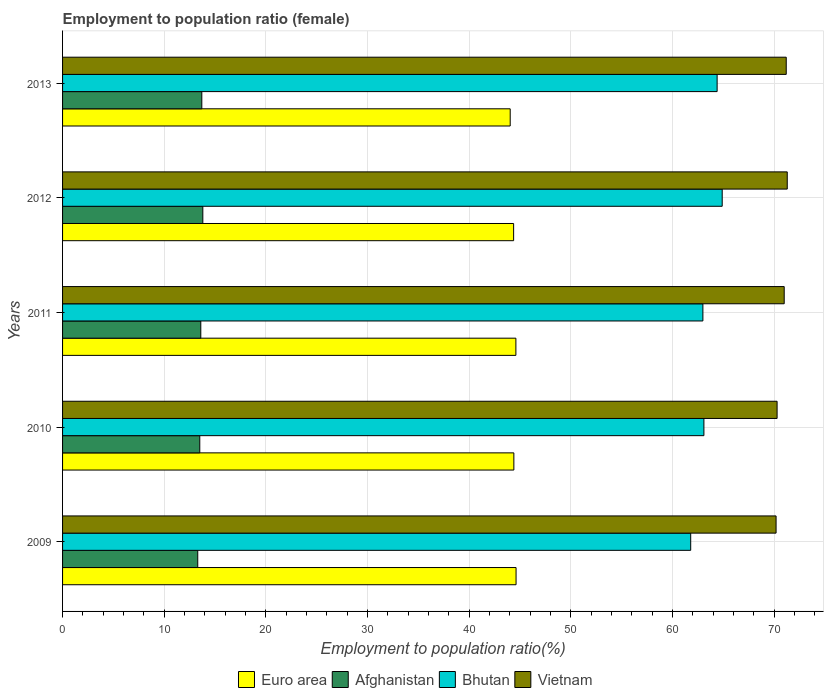How many different coloured bars are there?
Give a very brief answer. 4. How many groups of bars are there?
Offer a terse response. 5. Are the number of bars per tick equal to the number of legend labels?
Provide a succinct answer. Yes. Are the number of bars on each tick of the Y-axis equal?
Offer a terse response. Yes. How many bars are there on the 2nd tick from the top?
Keep it short and to the point. 4. How many bars are there on the 2nd tick from the bottom?
Your answer should be very brief. 4. What is the employment to population ratio in Afghanistan in 2011?
Offer a terse response. 13.6. Across all years, what is the maximum employment to population ratio in Afghanistan?
Offer a terse response. 13.8. Across all years, what is the minimum employment to population ratio in Afghanistan?
Ensure brevity in your answer.  13.3. What is the total employment to population ratio in Vietnam in the graph?
Offer a very short reply. 354. What is the difference between the employment to population ratio in Vietnam in 2009 and that in 2011?
Make the answer very short. -0.8. What is the difference between the employment to population ratio in Bhutan in 2013 and the employment to population ratio in Euro area in 2012?
Your answer should be very brief. 20.02. What is the average employment to population ratio in Bhutan per year?
Your answer should be compact. 63.44. In the year 2012, what is the difference between the employment to population ratio in Bhutan and employment to population ratio in Euro area?
Offer a very short reply. 20.52. What is the ratio of the employment to population ratio in Euro area in 2010 to that in 2011?
Give a very brief answer. 1. What is the difference between the highest and the second highest employment to population ratio in Euro area?
Your answer should be very brief. 0.02. What is the difference between the highest and the lowest employment to population ratio in Vietnam?
Keep it short and to the point. 1.1. In how many years, is the employment to population ratio in Bhutan greater than the average employment to population ratio in Bhutan taken over all years?
Your response must be concise. 2. Is the sum of the employment to population ratio in Bhutan in 2010 and 2012 greater than the maximum employment to population ratio in Afghanistan across all years?
Offer a very short reply. Yes. What does the 4th bar from the top in 2011 represents?
Give a very brief answer. Euro area. What does the 4th bar from the bottom in 2011 represents?
Your answer should be compact. Vietnam. Is it the case that in every year, the sum of the employment to population ratio in Vietnam and employment to population ratio in Bhutan is greater than the employment to population ratio in Afghanistan?
Give a very brief answer. Yes. How many years are there in the graph?
Provide a short and direct response. 5. Are the values on the major ticks of X-axis written in scientific E-notation?
Ensure brevity in your answer.  No. Does the graph contain any zero values?
Ensure brevity in your answer.  No. Where does the legend appear in the graph?
Offer a terse response. Bottom center. How are the legend labels stacked?
Your response must be concise. Horizontal. What is the title of the graph?
Keep it short and to the point. Employment to population ratio (female). What is the Employment to population ratio(%) of Euro area in 2009?
Provide a short and direct response. 44.62. What is the Employment to population ratio(%) in Afghanistan in 2009?
Make the answer very short. 13.3. What is the Employment to population ratio(%) of Bhutan in 2009?
Give a very brief answer. 61.8. What is the Employment to population ratio(%) of Vietnam in 2009?
Make the answer very short. 70.2. What is the Employment to population ratio(%) of Euro area in 2010?
Your answer should be very brief. 44.4. What is the Employment to population ratio(%) of Afghanistan in 2010?
Provide a succinct answer. 13.5. What is the Employment to population ratio(%) in Bhutan in 2010?
Make the answer very short. 63.1. What is the Employment to population ratio(%) in Vietnam in 2010?
Keep it short and to the point. 70.3. What is the Employment to population ratio(%) in Euro area in 2011?
Provide a short and direct response. 44.6. What is the Employment to population ratio(%) of Afghanistan in 2011?
Your answer should be compact. 13.6. What is the Employment to population ratio(%) in Bhutan in 2011?
Offer a terse response. 63. What is the Employment to population ratio(%) in Vietnam in 2011?
Offer a very short reply. 71. What is the Employment to population ratio(%) of Euro area in 2012?
Give a very brief answer. 44.38. What is the Employment to population ratio(%) of Afghanistan in 2012?
Give a very brief answer. 13.8. What is the Employment to population ratio(%) of Bhutan in 2012?
Provide a succinct answer. 64.9. What is the Employment to population ratio(%) of Vietnam in 2012?
Provide a succinct answer. 71.3. What is the Employment to population ratio(%) of Euro area in 2013?
Provide a succinct answer. 44.04. What is the Employment to population ratio(%) in Afghanistan in 2013?
Offer a very short reply. 13.7. What is the Employment to population ratio(%) in Bhutan in 2013?
Provide a short and direct response. 64.4. What is the Employment to population ratio(%) of Vietnam in 2013?
Your response must be concise. 71.2. Across all years, what is the maximum Employment to population ratio(%) in Euro area?
Make the answer very short. 44.62. Across all years, what is the maximum Employment to population ratio(%) in Afghanistan?
Make the answer very short. 13.8. Across all years, what is the maximum Employment to population ratio(%) in Bhutan?
Ensure brevity in your answer.  64.9. Across all years, what is the maximum Employment to population ratio(%) of Vietnam?
Make the answer very short. 71.3. Across all years, what is the minimum Employment to population ratio(%) in Euro area?
Ensure brevity in your answer.  44.04. Across all years, what is the minimum Employment to population ratio(%) of Afghanistan?
Give a very brief answer. 13.3. Across all years, what is the minimum Employment to population ratio(%) of Bhutan?
Your answer should be very brief. 61.8. Across all years, what is the minimum Employment to population ratio(%) in Vietnam?
Offer a terse response. 70.2. What is the total Employment to population ratio(%) in Euro area in the graph?
Your answer should be very brief. 222.04. What is the total Employment to population ratio(%) in Afghanistan in the graph?
Provide a succinct answer. 67.9. What is the total Employment to population ratio(%) of Bhutan in the graph?
Your response must be concise. 317.2. What is the total Employment to population ratio(%) in Vietnam in the graph?
Offer a very short reply. 354. What is the difference between the Employment to population ratio(%) of Euro area in 2009 and that in 2010?
Provide a short and direct response. 0.22. What is the difference between the Employment to population ratio(%) of Afghanistan in 2009 and that in 2010?
Provide a succinct answer. -0.2. What is the difference between the Employment to population ratio(%) in Bhutan in 2009 and that in 2010?
Provide a short and direct response. -1.3. What is the difference between the Employment to population ratio(%) in Vietnam in 2009 and that in 2010?
Provide a succinct answer. -0.1. What is the difference between the Employment to population ratio(%) in Euro area in 2009 and that in 2011?
Give a very brief answer. 0.02. What is the difference between the Employment to population ratio(%) of Afghanistan in 2009 and that in 2011?
Offer a terse response. -0.3. What is the difference between the Employment to population ratio(%) in Bhutan in 2009 and that in 2011?
Your response must be concise. -1.2. What is the difference between the Employment to population ratio(%) in Euro area in 2009 and that in 2012?
Ensure brevity in your answer.  0.24. What is the difference between the Employment to population ratio(%) in Bhutan in 2009 and that in 2012?
Your answer should be very brief. -3.1. What is the difference between the Employment to population ratio(%) in Vietnam in 2009 and that in 2012?
Offer a very short reply. -1.1. What is the difference between the Employment to population ratio(%) of Euro area in 2009 and that in 2013?
Keep it short and to the point. 0.58. What is the difference between the Employment to population ratio(%) of Vietnam in 2009 and that in 2013?
Offer a terse response. -1. What is the difference between the Employment to population ratio(%) of Euro area in 2010 and that in 2011?
Make the answer very short. -0.2. What is the difference between the Employment to population ratio(%) in Afghanistan in 2010 and that in 2011?
Your answer should be compact. -0.1. What is the difference between the Employment to population ratio(%) of Bhutan in 2010 and that in 2011?
Keep it short and to the point. 0.1. What is the difference between the Employment to population ratio(%) in Euro area in 2010 and that in 2012?
Your response must be concise. 0.02. What is the difference between the Employment to population ratio(%) in Afghanistan in 2010 and that in 2012?
Your response must be concise. -0.3. What is the difference between the Employment to population ratio(%) of Euro area in 2010 and that in 2013?
Give a very brief answer. 0.36. What is the difference between the Employment to population ratio(%) of Euro area in 2011 and that in 2012?
Your answer should be compact. 0.22. What is the difference between the Employment to population ratio(%) in Vietnam in 2011 and that in 2012?
Give a very brief answer. -0.3. What is the difference between the Employment to population ratio(%) of Euro area in 2011 and that in 2013?
Your answer should be compact. 0.56. What is the difference between the Employment to population ratio(%) in Afghanistan in 2011 and that in 2013?
Give a very brief answer. -0.1. What is the difference between the Employment to population ratio(%) in Bhutan in 2011 and that in 2013?
Keep it short and to the point. -1.4. What is the difference between the Employment to population ratio(%) in Euro area in 2012 and that in 2013?
Give a very brief answer. 0.34. What is the difference between the Employment to population ratio(%) of Afghanistan in 2012 and that in 2013?
Ensure brevity in your answer.  0.1. What is the difference between the Employment to population ratio(%) of Bhutan in 2012 and that in 2013?
Offer a terse response. 0.5. What is the difference between the Employment to population ratio(%) in Euro area in 2009 and the Employment to population ratio(%) in Afghanistan in 2010?
Provide a short and direct response. 31.12. What is the difference between the Employment to population ratio(%) of Euro area in 2009 and the Employment to population ratio(%) of Bhutan in 2010?
Ensure brevity in your answer.  -18.48. What is the difference between the Employment to population ratio(%) of Euro area in 2009 and the Employment to population ratio(%) of Vietnam in 2010?
Your answer should be compact. -25.68. What is the difference between the Employment to population ratio(%) in Afghanistan in 2009 and the Employment to population ratio(%) in Bhutan in 2010?
Provide a short and direct response. -49.8. What is the difference between the Employment to population ratio(%) in Afghanistan in 2009 and the Employment to population ratio(%) in Vietnam in 2010?
Your response must be concise. -57. What is the difference between the Employment to population ratio(%) of Bhutan in 2009 and the Employment to population ratio(%) of Vietnam in 2010?
Your answer should be compact. -8.5. What is the difference between the Employment to population ratio(%) in Euro area in 2009 and the Employment to population ratio(%) in Afghanistan in 2011?
Your answer should be compact. 31.02. What is the difference between the Employment to population ratio(%) of Euro area in 2009 and the Employment to population ratio(%) of Bhutan in 2011?
Provide a short and direct response. -18.38. What is the difference between the Employment to population ratio(%) of Euro area in 2009 and the Employment to population ratio(%) of Vietnam in 2011?
Ensure brevity in your answer.  -26.38. What is the difference between the Employment to population ratio(%) of Afghanistan in 2009 and the Employment to population ratio(%) of Bhutan in 2011?
Keep it short and to the point. -49.7. What is the difference between the Employment to population ratio(%) in Afghanistan in 2009 and the Employment to population ratio(%) in Vietnam in 2011?
Make the answer very short. -57.7. What is the difference between the Employment to population ratio(%) of Bhutan in 2009 and the Employment to population ratio(%) of Vietnam in 2011?
Provide a succinct answer. -9.2. What is the difference between the Employment to population ratio(%) of Euro area in 2009 and the Employment to population ratio(%) of Afghanistan in 2012?
Your answer should be very brief. 30.82. What is the difference between the Employment to population ratio(%) of Euro area in 2009 and the Employment to population ratio(%) of Bhutan in 2012?
Ensure brevity in your answer.  -20.28. What is the difference between the Employment to population ratio(%) of Euro area in 2009 and the Employment to population ratio(%) of Vietnam in 2012?
Provide a short and direct response. -26.68. What is the difference between the Employment to population ratio(%) in Afghanistan in 2009 and the Employment to population ratio(%) in Bhutan in 2012?
Ensure brevity in your answer.  -51.6. What is the difference between the Employment to population ratio(%) in Afghanistan in 2009 and the Employment to population ratio(%) in Vietnam in 2012?
Your response must be concise. -58. What is the difference between the Employment to population ratio(%) in Euro area in 2009 and the Employment to population ratio(%) in Afghanistan in 2013?
Keep it short and to the point. 30.92. What is the difference between the Employment to population ratio(%) of Euro area in 2009 and the Employment to population ratio(%) of Bhutan in 2013?
Provide a succinct answer. -19.78. What is the difference between the Employment to population ratio(%) of Euro area in 2009 and the Employment to population ratio(%) of Vietnam in 2013?
Ensure brevity in your answer.  -26.58. What is the difference between the Employment to population ratio(%) in Afghanistan in 2009 and the Employment to population ratio(%) in Bhutan in 2013?
Offer a very short reply. -51.1. What is the difference between the Employment to population ratio(%) in Afghanistan in 2009 and the Employment to population ratio(%) in Vietnam in 2013?
Ensure brevity in your answer.  -57.9. What is the difference between the Employment to population ratio(%) in Bhutan in 2009 and the Employment to population ratio(%) in Vietnam in 2013?
Provide a short and direct response. -9.4. What is the difference between the Employment to population ratio(%) of Euro area in 2010 and the Employment to population ratio(%) of Afghanistan in 2011?
Provide a short and direct response. 30.8. What is the difference between the Employment to population ratio(%) in Euro area in 2010 and the Employment to population ratio(%) in Bhutan in 2011?
Provide a succinct answer. -18.6. What is the difference between the Employment to population ratio(%) of Euro area in 2010 and the Employment to population ratio(%) of Vietnam in 2011?
Make the answer very short. -26.6. What is the difference between the Employment to population ratio(%) of Afghanistan in 2010 and the Employment to population ratio(%) of Bhutan in 2011?
Make the answer very short. -49.5. What is the difference between the Employment to population ratio(%) in Afghanistan in 2010 and the Employment to population ratio(%) in Vietnam in 2011?
Give a very brief answer. -57.5. What is the difference between the Employment to population ratio(%) of Euro area in 2010 and the Employment to population ratio(%) of Afghanistan in 2012?
Provide a short and direct response. 30.6. What is the difference between the Employment to population ratio(%) in Euro area in 2010 and the Employment to population ratio(%) in Bhutan in 2012?
Make the answer very short. -20.5. What is the difference between the Employment to population ratio(%) in Euro area in 2010 and the Employment to population ratio(%) in Vietnam in 2012?
Offer a terse response. -26.9. What is the difference between the Employment to population ratio(%) of Afghanistan in 2010 and the Employment to population ratio(%) of Bhutan in 2012?
Offer a terse response. -51.4. What is the difference between the Employment to population ratio(%) in Afghanistan in 2010 and the Employment to population ratio(%) in Vietnam in 2012?
Your response must be concise. -57.8. What is the difference between the Employment to population ratio(%) of Bhutan in 2010 and the Employment to population ratio(%) of Vietnam in 2012?
Your answer should be compact. -8.2. What is the difference between the Employment to population ratio(%) of Euro area in 2010 and the Employment to population ratio(%) of Afghanistan in 2013?
Give a very brief answer. 30.7. What is the difference between the Employment to population ratio(%) in Euro area in 2010 and the Employment to population ratio(%) in Bhutan in 2013?
Your answer should be compact. -20. What is the difference between the Employment to population ratio(%) of Euro area in 2010 and the Employment to population ratio(%) of Vietnam in 2013?
Give a very brief answer. -26.8. What is the difference between the Employment to population ratio(%) in Afghanistan in 2010 and the Employment to population ratio(%) in Bhutan in 2013?
Ensure brevity in your answer.  -50.9. What is the difference between the Employment to population ratio(%) of Afghanistan in 2010 and the Employment to population ratio(%) of Vietnam in 2013?
Your answer should be compact. -57.7. What is the difference between the Employment to population ratio(%) in Euro area in 2011 and the Employment to population ratio(%) in Afghanistan in 2012?
Provide a succinct answer. 30.8. What is the difference between the Employment to population ratio(%) of Euro area in 2011 and the Employment to population ratio(%) of Bhutan in 2012?
Your response must be concise. -20.3. What is the difference between the Employment to population ratio(%) in Euro area in 2011 and the Employment to population ratio(%) in Vietnam in 2012?
Make the answer very short. -26.7. What is the difference between the Employment to population ratio(%) of Afghanistan in 2011 and the Employment to population ratio(%) of Bhutan in 2012?
Your answer should be compact. -51.3. What is the difference between the Employment to population ratio(%) of Afghanistan in 2011 and the Employment to population ratio(%) of Vietnam in 2012?
Your answer should be very brief. -57.7. What is the difference between the Employment to population ratio(%) in Euro area in 2011 and the Employment to population ratio(%) in Afghanistan in 2013?
Your answer should be compact. 30.9. What is the difference between the Employment to population ratio(%) in Euro area in 2011 and the Employment to population ratio(%) in Bhutan in 2013?
Provide a short and direct response. -19.8. What is the difference between the Employment to population ratio(%) in Euro area in 2011 and the Employment to population ratio(%) in Vietnam in 2013?
Your answer should be very brief. -26.6. What is the difference between the Employment to population ratio(%) of Afghanistan in 2011 and the Employment to population ratio(%) of Bhutan in 2013?
Your answer should be compact. -50.8. What is the difference between the Employment to population ratio(%) of Afghanistan in 2011 and the Employment to population ratio(%) of Vietnam in 2013?
Keep it short and to the point. -57.6. What is the difference between the Employment to population ratio(%) of Bhutan in 2011 and the Employment to population ratio(%) of Vietnam in 2013?
Ensure brevity in your answer.  -8.2. What is the difference between the Employment to population ratio(%) in Euro area in 2012 and the Employment to population ratio(%) in Afghanistan in 2013?
Offer a very short reply. 30.68. What is the difference between the Employment to population ratio(%) of Euro area in 2012 and the Employment to population ratio(%) of Bhutan in 2013?
Give a very brief answer. -20.02. What is the difference between the Employment to population ratio(%) of Euro area in 2012 and the Employment to population ratio(%) of Vietnam in 2013?
Offer a very short reply. -26.82. What is the difference between the Employment to population ratio(%) in Afghanistan in 2012 and the Employment to population ratio(%) in Bhutan in 2013?
Offer a terse response. -50.6. What is the difference between the Employment to population ratio(%) of Afghanistan in 2012 and the Employment to population ratio(%) of Vietnam in 2013?
Give a very brief answer. -57.4. What is the difference between the Employment to population ratio(%) of Bhutan in 2012 and the Employment to population ratio(%) of Vietnam in 2013?
Offer a very short reply. -6.3. What is the average Employment to population ratio(%) in Euro area per year?
Provide a succinct answer. 44.41. What is the average Employment to population ratio(%) of Afghanistan per year?
Provide a short and direct response. 13.58. What is the average Employment to population ratio(%) in Bhutan per year?
Give a very brief answer. 63.44. What is the average Employment to population ratio(%) of Vietnam per year?
Make the answer very short. 70.8. In the year 2009, what is the difference between the Employment to population ratio(%) in Euro area and Employment to population ratio(%) in Afghanistan?
Offer a very short reply. 31.32. In the year 2009, what is the difference between the Employment to population ratio(%) of Euro area and Employment to population ratio(%) of Bhutan?
Offer a very short reply. -17.18. In the year 2009, what is the difference between the Employment to population ratio(%) in Euro area and Employment to population ratio(%) in Vietnam?
Offer a very short reply. -25.58. In the year 2009, what is the difference between the Employment to population ratio(%) in Afghanistan and Employment to population ratio(%) in Bhutan?
Make the answer very short. -48.5. In the year 2009, what is the difference between the Employment to population ratio(%) in Afghanistan and Employment to population ratio(%) in Vietnam?
Keep it short and to the point. -56.9. In the year 2010, what is the difference between the Employment to population ratio(%) of Euro area and Employment to population ratio(%) of Afghanistan?
Offer a very short reply. 30.9. In the year 2010, what is the difference between the Employment to population ratio(%) of Euro area and Employment to population ratio(%) of Bhutan?
Provide a short and direct response. -18.7. In the year 2010, what is the difference between the Employment to population ratio(%) of Euro area and Employment to population ratio(%) of Vietnam?
Ensure brevity in your answer.  -25.9. In the year 2010, what is the difference between the Employment to population ratio(%) in Afghanistan and Employment to population ratio(%) in Bhutan?
Your answer should be very brief. -49.6. In the year 2010, what is the difference between the Employment to population ratio(%) of Afghanistan and Employment to population ratio(%) of Vietnam?
Give a very brief answer. -56.8. In the year 2010, what is the difference between the Employment to population ratio(%) of Bhutan and Employment to population ratio(%) of Vietnam?
Offer a terse response. -7.2. In the year 2011, what is the difference between the Employment to population ratio(%) in Euro area and Employment to population ratio(%) in Afghanistan?
Provide a succinct answer. 31. In the year 2011, what is the difference between the Employment to population ratio(%) of Euro area and Employment to population ratio(%) of Bhutan?
Ensure brevity in your answer.  -18.4. In the year 2011, what is the difference between the Employment to population ratio(%) of Euro area and Employment to population ratio(%) of Vietnam?
Make the answer very short. -26.4. In the year 2011, what is the difference between the Employment to population ratio(%) of Afghanistan and Employment to population ratio(%) of Bhutan?
Your response must be concise. -49.4. In the year 2011, what is the difference between the Employment to population ratio(%) of Afghanistan and Employment to population ratio(%) of Vietnam?
Your response must be concise. -57.4. In the year 2011, what is the difference between the Employment to population ratio(%) of Bhutan and Employment to population ratio(%) of Vietnam?
Offer a terse response. -8. In the year 2012, what is the difference between the Employment to population ratio(%) of Euro area and Employment to population ratio(%) of Afghanistan?
Provide a short and direct response. 30.58. In the year 2012, what is the difference between the Employment to population ratio(%) in Euro area and Employment to population ratio(%) in Bhutan?
Your answer should be very brief. -20.52. In the year 2012, what is the difference between the Employment to population ratio(%) of Euro area and Employment to population ratio(%) of Vietnam?
Provide a succinct answer. -26.92. In the year 2012, what is the difference between the Employment to population ratio(%) in Afghanistan and Employment to population ratio(%) in Bhutan?
Offer a terse response. -51.1. In the year 2012, what is the difference between the Employment to population ratio(%) in Afghanistan and Employment to population ratio(%) in Vietnam?
Ensure brevity in your answer.  -57.5. In the year 2012, what is the difference between the Employment to population ratio(%) in Bhutan and Employment to population ratio(%) in Vietnam?
Give a very brief answer. -6.4. In the year 2013, what is the difference between the Employment to population ratio(%) of Euro area and Employment to population ratio(%) of Afghanistan?
Provide a succinct answer. 30.34. In the year 2013, what is the difference between the Employment to population ratio(%) in Euro area and Employment to population ratio(%) in Bhutan?
Provide a short and direct response. -20.36. In the year 2013, what is the difference between the Employment to population ratio(%) of Euro area and Employment to population ratio(%) of Vietnam?
Give a very brief answer. -27.16. In the year 2013, what is the difference between the Employment to population ratio(%) in Afghanistan and Employment to population ratio(%) in Bhutan?
Offer a terse response. -50.7. In the year 2013, what is the difference between the Employment to population ratio(%) of Afghanistan and Employment to population ratio(%) of Vietnam?
Provide a short and direct response. -57.5. In the year 2013, what is the difference between the Employment to population ratio(%) in Bhutan and Employment to population ratio(%) in Vietnam?
Provide a short and direct response. -6.8. What is the ratio of the Employment to population ratio(%) in Euro area in 2009 to that in 2010?
Make the answer very short. 1. What is the ratio of the Employment to population ratio(%) of Afghanistan in 2009 to that in 2010?
Make the answer very short. 0.99. What is the ratio of the Employment to population ratio(%) in Bhutan in 2009 to that in 2010?
Keep it short and to the point. 0.98. What is the ratio of the Employment to population ratio(%) of Vietnam in 2009 to that in 2010?
Your answer should be compact. 1. What is the ratio of the Employment to population ratio(%) of Afghanistan in 2009 to that in 2011?
Give a very brief answer. 0.98. What is the ratio of the Employment to population ratio(%) of Bhutan in 2009 to that in 2011?
Your response must be concise. 0.98. What is the ratio of the Employment to population ratio(%) in Vietnam in 2009 to that in 2011?
Your answer should be compact. 0.99. What is the ratio of the Employment to population ratio(%) of Euro area in 2009 to that in 2012?
Provide a succinct answer. 1.01. What is the ratio of the Employment to population ratio(%) in Afghanistan in 2009 to that in 2012?
Your answer should be very brief. 0.96. What is the ratio of the Employment to population ratio(%) of Bhutan in 2009 to that in 2012?
Your answer should be compact. 0.95. What is the ratio of the Employment to population ratio(%) in Vietnam in 2009 to that in 2012?
Keep it short and to the point. 0.98. What is the ratio of the Employment to population ratio(%) of Euro area in 2009 to that in 2013?
Provide a succinct answer. 1.01. What is the ratio of the Employment to population ratio(%) of Afghanistan in 2009 to that in 2013?
Give a very brief answer. 0.97. What is the ratio of the Employment to population ratio(%) in Bhutan in 2009 to that in 2013?
Give a very brief answer. 0.96. What is the ratio of the Employment to population ratio(%) of Vietnam in 2010 to that in 2011?
Your response must be concise. 0.99. What is the ratio of the Employment to population ratio(%) of Euro area in 2010 to that in 2012?
Ensure brevity in your answer.  1. What is the ratio of the Employment to population ratio(%) of Afghanistan in 2010 to that in 2012?
Your answer should be very brief. 0.98. What is the ratio of the Employment to population ratio(%) of Bhutan in 2010 to that in 2012?
Give a very brief answer. 0.97. What is the ratio of the Employment to population ratio(%) of Euro area in 2010 to that in 2013?
Provide a short and direct response. 1.01. What is the ratio of the Employment to population ratio(%) in Afghanistan in 2010 to that in 2013?
Your answer should be very brief. 0.99. What is the ratio of the Employment to population ratio(%) in Bhutan in 2010 to that in 2013?
Provide a succinct answer. 0.98. What is the ratio of the Employment to population ratio(%) of Vietnam in 2010 to that in 2013?
Your answer should be very brief. 0.99. What is the ratio of the Employment to population ratio(%) of Euro area in 2011 to that in 2012?
Make the answer very short. 1. What is the ratio of the Employment to population ratio(%) in Afghanistan in 2011 to that in 2012?
Keep it short and to the point. 0.99. What is the ratio of the Employment to population ratio(%) of Bhutan in 2011 to that in 2012?
Provide a short and direct response. 0.97. What is the ratio of the Employment to population ratio(%) of Euro area in 2011 to that in 2013?
Offer a very short reply. 1.01. What is the ratio of the Employment to population ratio(%) in Afghanistan in 2011 to that in 2013?
Keep it short and to the point. 0.99. What is the ratio of the Employment to population ratio(%) of Bhutan in 2011 to that in 2013?
Your answer should be very brief. 0.98. What is the ratio of the Employment to population ratio(%) in Euro area in 2012 to that in 2013?
Provide a succinct answer. 1.01. What is the ratio of the Employment to population ratio(%) of Afghanistan in 2012 to that in 2013?
Make the answer very short. 1.01. What is the ratio of the Employment to population ratio(%) in Vietnam in 2012 to that in 2013?
Offer a terse response. 1. What is the difference between the highest and the second highest Employment to population ratio(%) of Euro area?
Your answer should be very brief. 0.02. What is the difference between the highest and the second highest Employment to population ratio(%) of Afghanistan?
Offer a terse response. 0.1. What is the difference between the highest and the second highest Employment to population ratio(%) in Bhutan?
Keep it short and to the point. 0.5. What is the difference between the highest and the lowest Employment to population ratio(%) of Euro area?
Make the answer very short. 0.58. What is the difference between the highest and the lowest Employment to population ratio(%) in Vietnam?
Give a very brief answer. 1.1. 